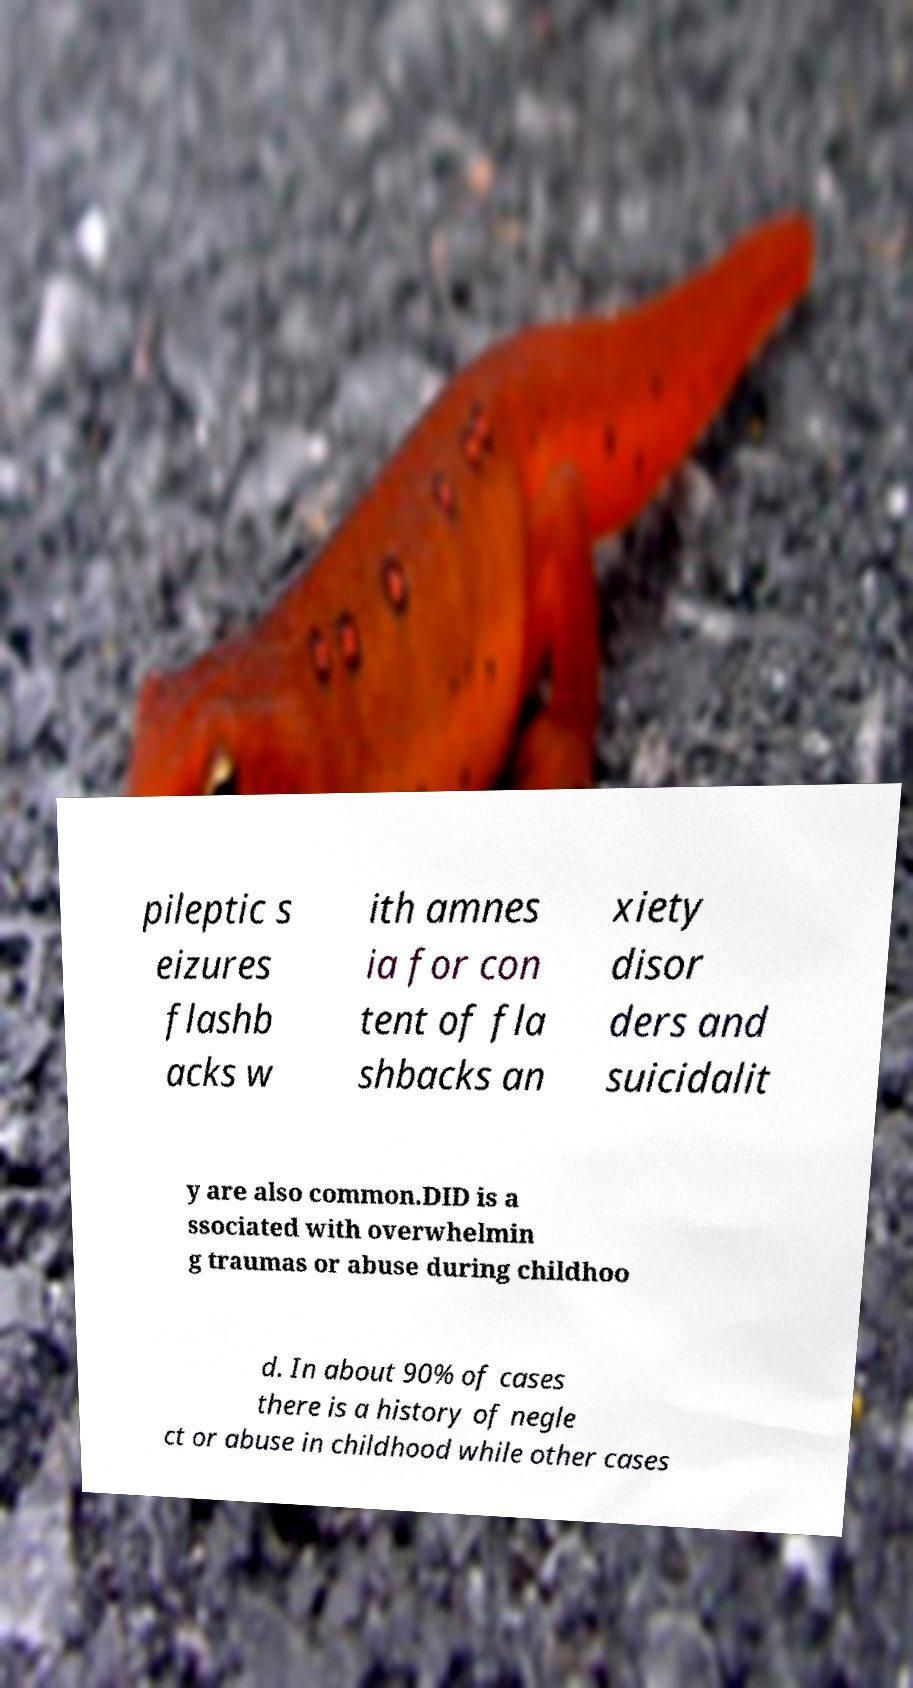Could you extract and type out the text from this image? pileptic s eizures flashb acks w ith amnes ia for con tent of fla shbacks an xiety disor ders and suicidalit y are also common.DID is a ssociated with overwhelmin g traumas or abuse during childhoo d. In about 90% of cases there is a history of negle ct or abuse in childhood while other cases 